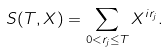<formula> <loc_0><loc_0><loc_500><loc_500>S ( T , X ) = \sum _ { 0 < r _ { j } \leq T } X ^ { i r _ { j } } .</formula> 